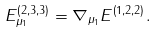<formula> <loc_0><loc_0><loc_500><loc_500>E _ { \mu _ { 1 } } ^ { \left ( 2 , 3 , 3 \right ) } = \nabla _ { \mu _ { 1 } } E ^ { \left ( 1 , 2 , 2 \right ) } .</formula> 